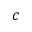<formula> <loc_0><loc_0><loc_500><loc_500>c</formula> 